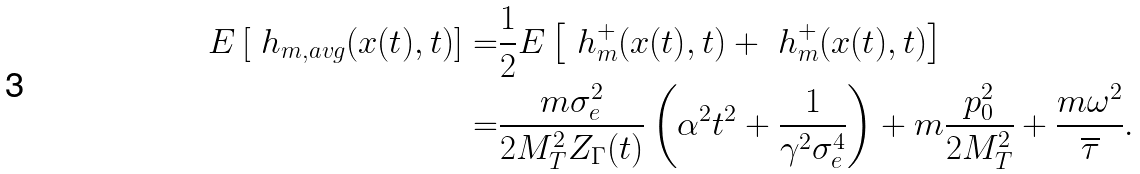<formula> <loc_0><loc_0><loc_500><loc_500>E \left [ \ h _ { m , a v g } ( x ( t ) , t ) \right ] = & \frac { 1 } { 2 } E \left [ \ h ^ { + } _ { m } ( x ( t ) , t ) + \ h ^ { + } _ { m } ( x ( t ) , t ) \right ] \\ = & \frac { m \sigma ^ { 2 } _ { e } } { 2 M ^ { 2 } _ { T } Z _ { \Gamma } ( t ) } \left ( \alpha ^ { 2 } t ^ { 2 } + \frac { 1 } { \gamma ^ { 2 } \sigma ^ { 4 } _ { e } } \right ) + m \frac { p ^ { 2 } _ { 0 } } { 2 M ^ { 2 } _ { T } } + \frac { m \omega ^ { 2 } } { \overline { \tau } } .</formula> 